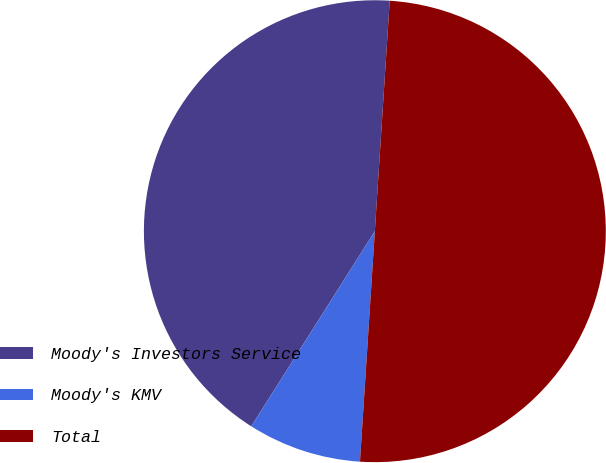Convert chart to OTSL. <chart><loc_0><loc_0><loc_500><loc_500><pie_chart><fcel>Moody's Investors Service<fcel>Moody's KMV<fcel>Total<nl><fcel>42.04%<fcel>7.96%<fcel>50.0%<nl></chart> 